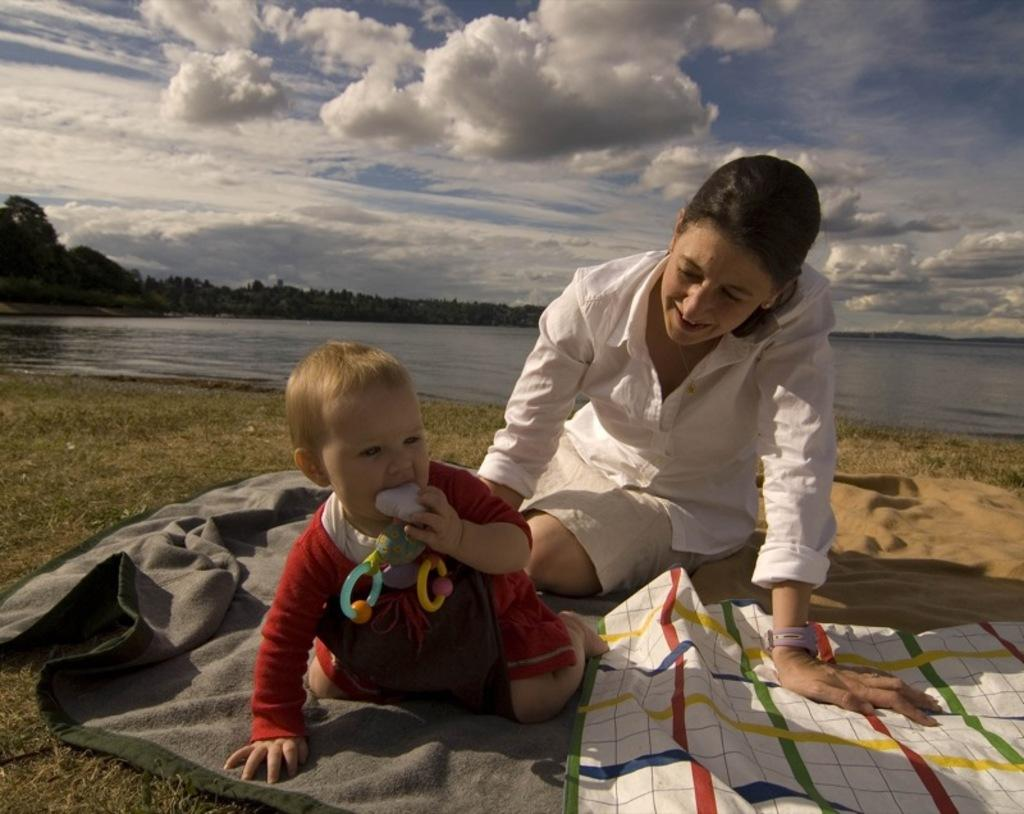Who is present in the image? There is a woman and a kid in the image. What are they sitting on? Both the woman and the kid are on blankets. What can be seen in the background of the image? There is water, trees, and clouds visible in the background. How many spiders are crawling on the woman's blanket in the image? There are no spiders visible in the image; the woman and kid are sitting on blankets with no spiders present. 